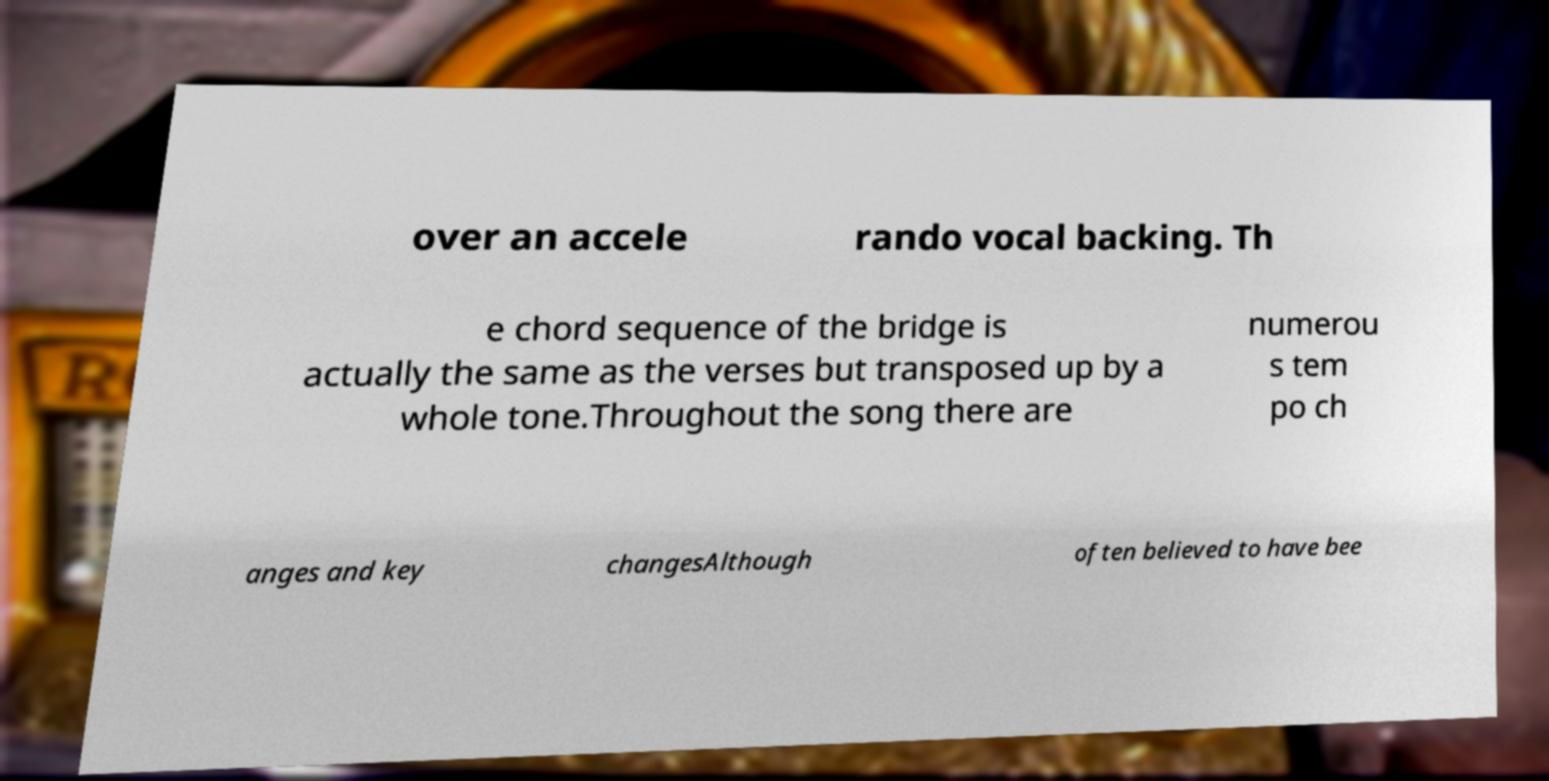Can you read and provide the text displayed in the image?This photo seems to have some interesting text. Can you extract and type it out for me? over an accele rando vocal backing. Th e chord sequence of the bridge is actually the same as the verses but transposed up by a whole tone.Throughout the song there are numerou s tem po ch anges and key changesAlthough often believed to have bee 